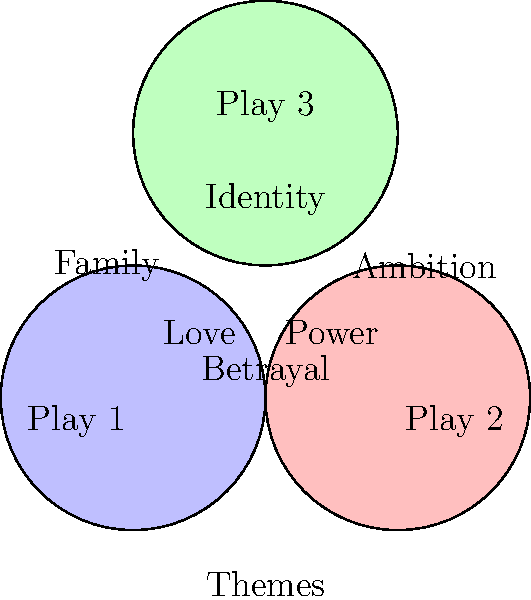Analyze the Venn diagram representing thematic elements in three plays by the same playwright. Which theme appears to be central and common to all three plays, and how might this reflect the playwright's recurring concerns or artistic vision? To answer this question, let's analyze the Venn diagram step-by-step:

1. Identify the three plays: The diagram shows three intersecting circles, each representing a play (Play 1, Play 2, and Play 3).

2. Locate the themes: The diagram includes six themes: Love, Power, Identity, Family, Ambition, and Betrayal.

3. Analyze the placement of themes:
   - "Love" is shared between Play 1 and Play 2
   - "Power" is shared between Play 2 and Play 3
   - "Identity" is shared between Play 1 and Play 3
   - "Family" appears only in Play 1
   - "Ambition" appears only in Play 2
   - "Betrayal" is at the center, where all three circles intersect

4. Interpret the central theme: "Betrayal" is the only theme positioned at the intersection of all three plays, indicating it is common to all of them.

5. Reflect on the playwright's vision: The centrality of "Betrayal" suggests that this theme is a recurring concern in the playwright's work. It may indicate that the playwright is particularly interested in exploring the complexities of trust, loyalty, and deception in human relationships across different contexts.

6. Consider the artistic implications: By consistently featuring betrayal, the playwright may be using this theme as a lens through which to examine other aspects of human nature and society. It could serve as a catalyst for character development, plot progression, or social commentary in their plays.
Answer: Betrayal; reflects the playwright's recurring interest in trust, loyalty, and deception in human relationships. 